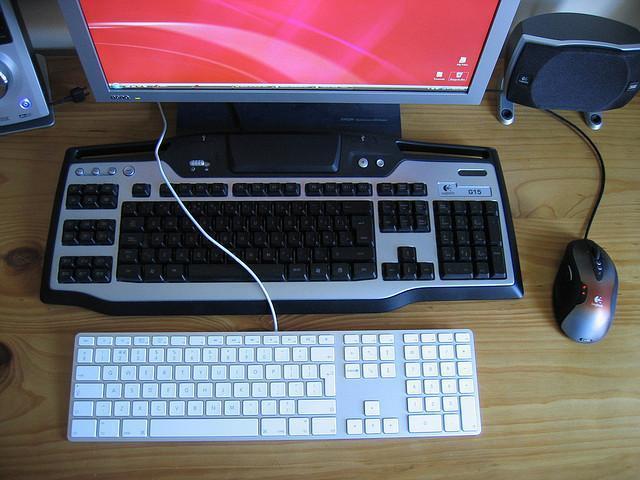How many keyboards are there?
Give a very brief answer. 2. How many keyboards are visible?
Give a very brief answer. 2. 